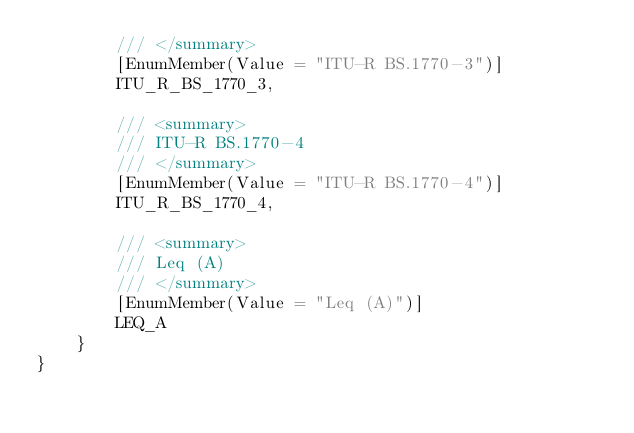<code> <loc_0><loc_0><loc_500><loc_500><_C#_>        /// </summary>
        [EnumMember(Value = "ITU-R BS.1770-3")]
        ITU_R_BS_1770_3,

        /// <summary>
        /// ITU-R BS.1770-4
        /// </summary>
        [EnumMember(Value = "ITU-R BS.1770-4")]
        ITU_R_BS_1770_4,

        /// <summary>
        /// Leq (A)
        /// </summary>
        [EnumMember(Value = "Leq (A)")]
        LEQ_A
    }
}
</code> 